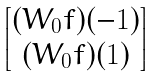<formula> <loc_0><loc_0><loc_500><loc_500>\begin{bmatrix} ( W _ { 0 } f ) ( - 1 ) \\ ( W _ { 0 } f ) ( 1 ) \end{bmatrix}</formula> 